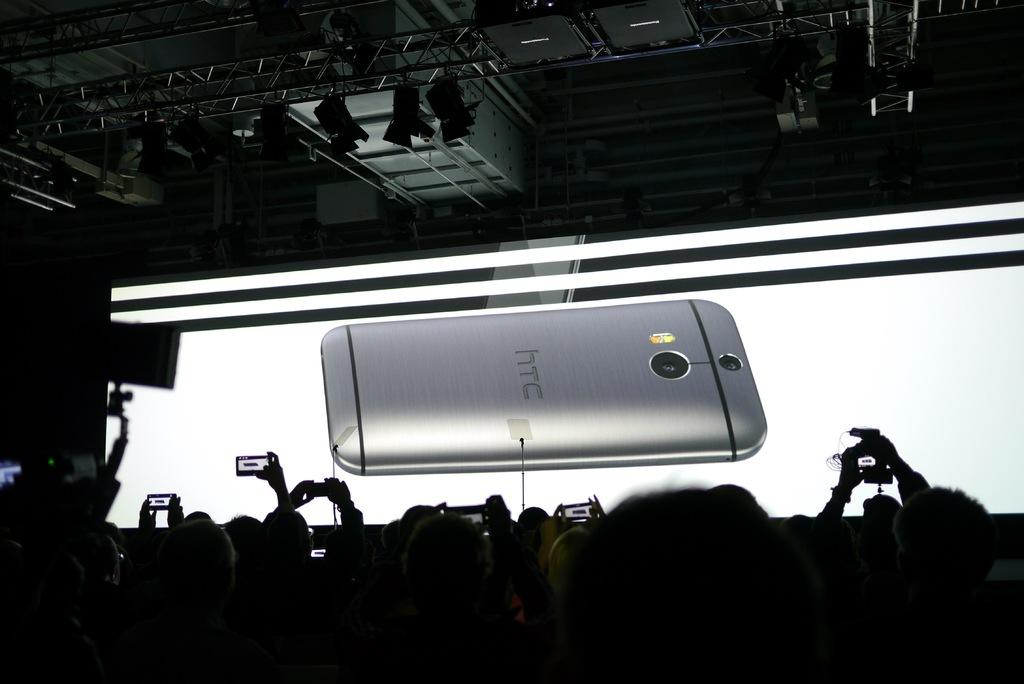<image>
Create a compact narrative representing the image presented. A cellphone with HTC written on the back. 